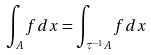Convert formula to latex. <formula><loc_0><loc_0><loc_500><loc_500>\int _ { A } f d x = \int _ { \tau ^ { - 1 } A } f d x</formula> 